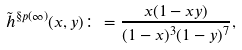Convert formula to latex. <formula><loc_0><loc_0><loc_500><loc_500>\tilde { h } ^ { \S p ( \infty ) } ( x , y ) \colon = \frac { x ( 1 - x y ) } { ( 1 - x ) ^ { 3 } ( 1 - y ) ^ { 7 } } ,</formula> 